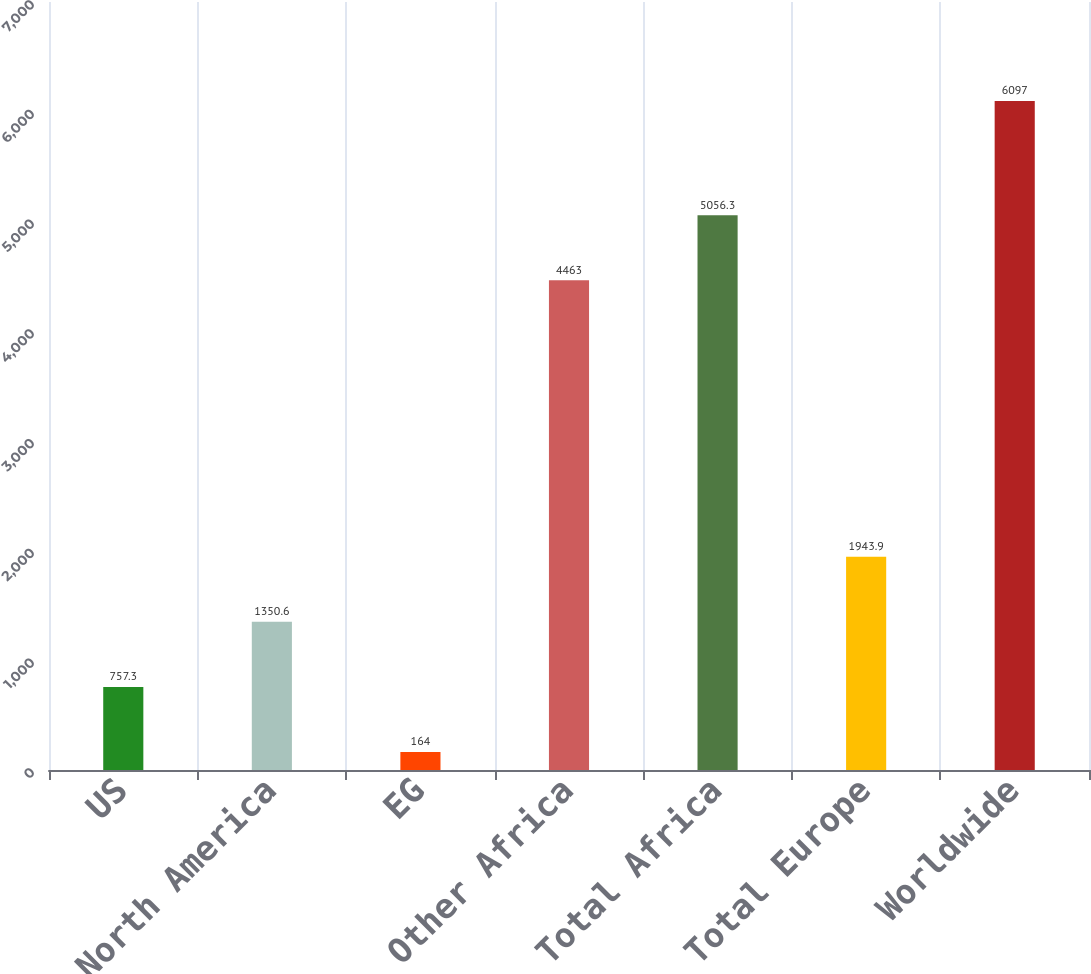Convert chart. <chart><loc_0><loc_0><loc_500><loc_500><bar_chart><fcel>US<fcel>Total North America<fcel>EG<fcel>Other Africa<fcel>Total Africa<fcel>Total Europe<fcel>Worldwide<nl><fcel>757.3<fcel>1350.6<fcel>164<fcel>4463<fcel>5056.3<fcel>1943.9<fcel>6097<nl></chart> 